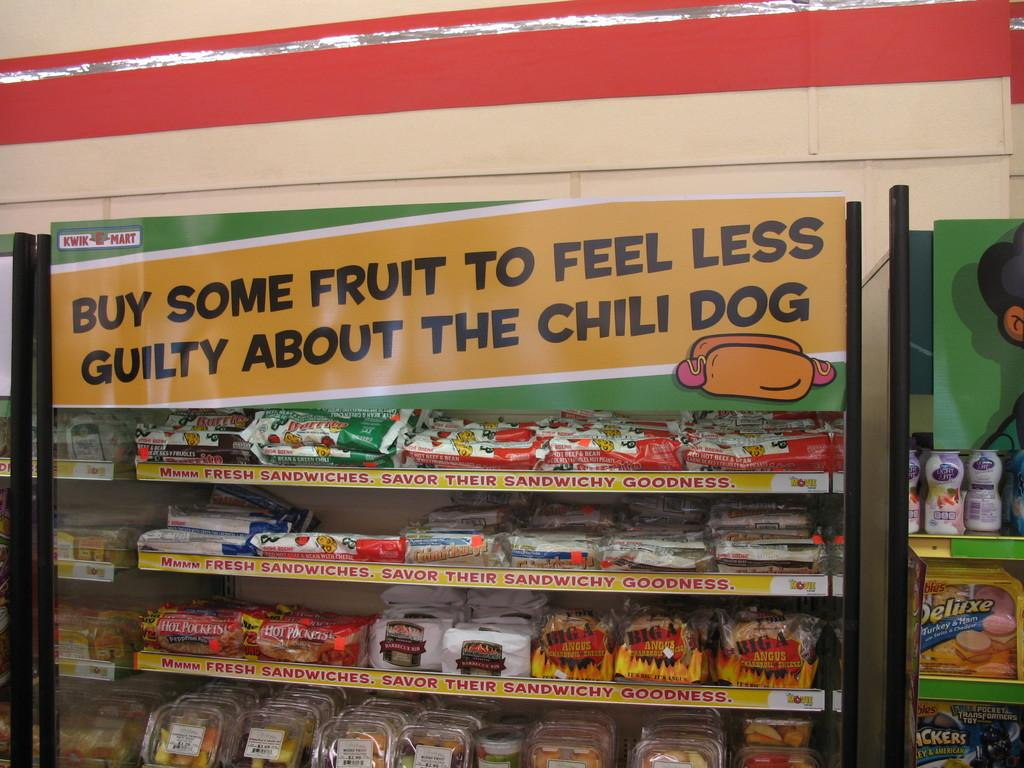<image>
Write a terse but informative summary of the picture. A display case with rows of sandwiches in wrappers 